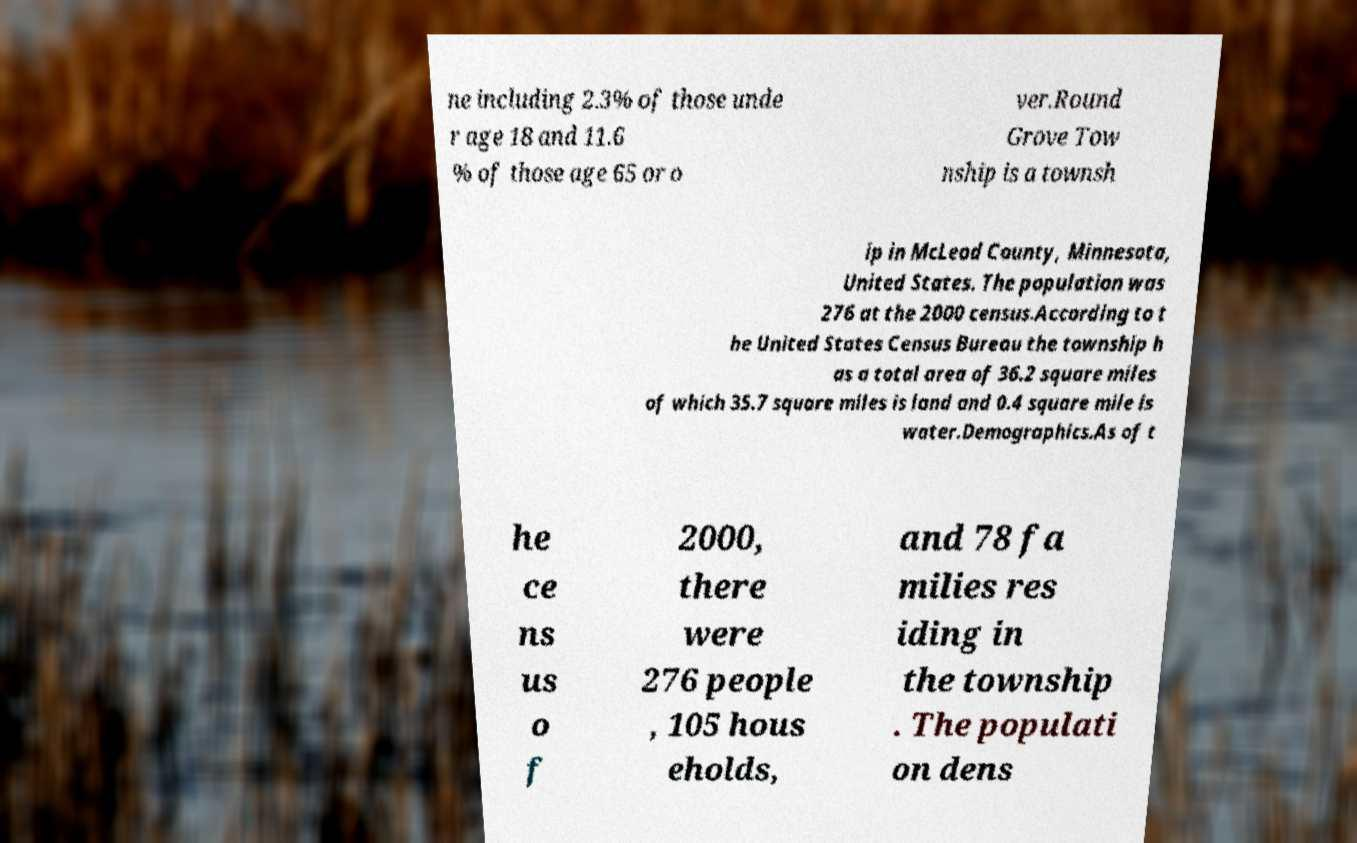For documentation purposes, I need the text within this image transcribed. Could you provide that? ne including 2.3% of those unde r age 18 and 11.6 % of those age 65 or o ver.Round Grove Tow nship is a townsh ip in McLeod County, Minnesota, United States. The population was 276 at the 2000 census.According to t he United States Census Bureau the township h as a total area of 36.2 square miles of which 35.7 square miles is land and 0.4 square mile is water.Demographics.As of t he ce ns us o f 2000, there were 276 people , 105 hous eholds, and 78 fa milies res iding in the township . The populati on dens 